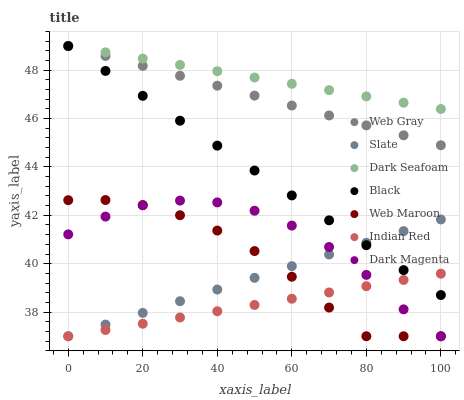Does Indian Red have the minimum area under the curve?
Answer yes or no. Yes. Does Dark Seafoam have the maximum area under the curve?
Answer yes or no. Yes. Does Dark Magenta have the minimum area under the curve?
Answer yes or no. No. Does Dark Magenta have the maximum area under the curve?
Answer yes or no. No. Is Black the smoothest?
Answer yes or no. Yes. Is Web Maroon the roughest?
Answer yes or no. Yes. Is Dark Magenta the smoothest?
Answer yes or no. No. Is Dark Magenta the roughest?
Answer yes or no. No. Does Dark Magenta have the lowest value?
Answer yes or no. Yes. Does Dark Seafoam have the lowest value?
Answer yes or no. No. Does Black have the highest value?
Answer yes or no. Yes. Does Dark Magenta have the highest value?
Answer yes or no. No. Is Dark Magenta less than Black?
Answer yes or no. Yes. Is Dark Seafoam greater than Slate?
Answer yes or no. Yes. Does Web Maroon intersect Dark Magenta?
Answer yes or no. Yes. Is Web Maroon less than Dark Magenta?
Answer yes or no. No. Is Web Maroon greater than Dark Magenta?
Answer yes or no. No. Does Dark Magenta intersect Black?
Answer yes or no. No. 